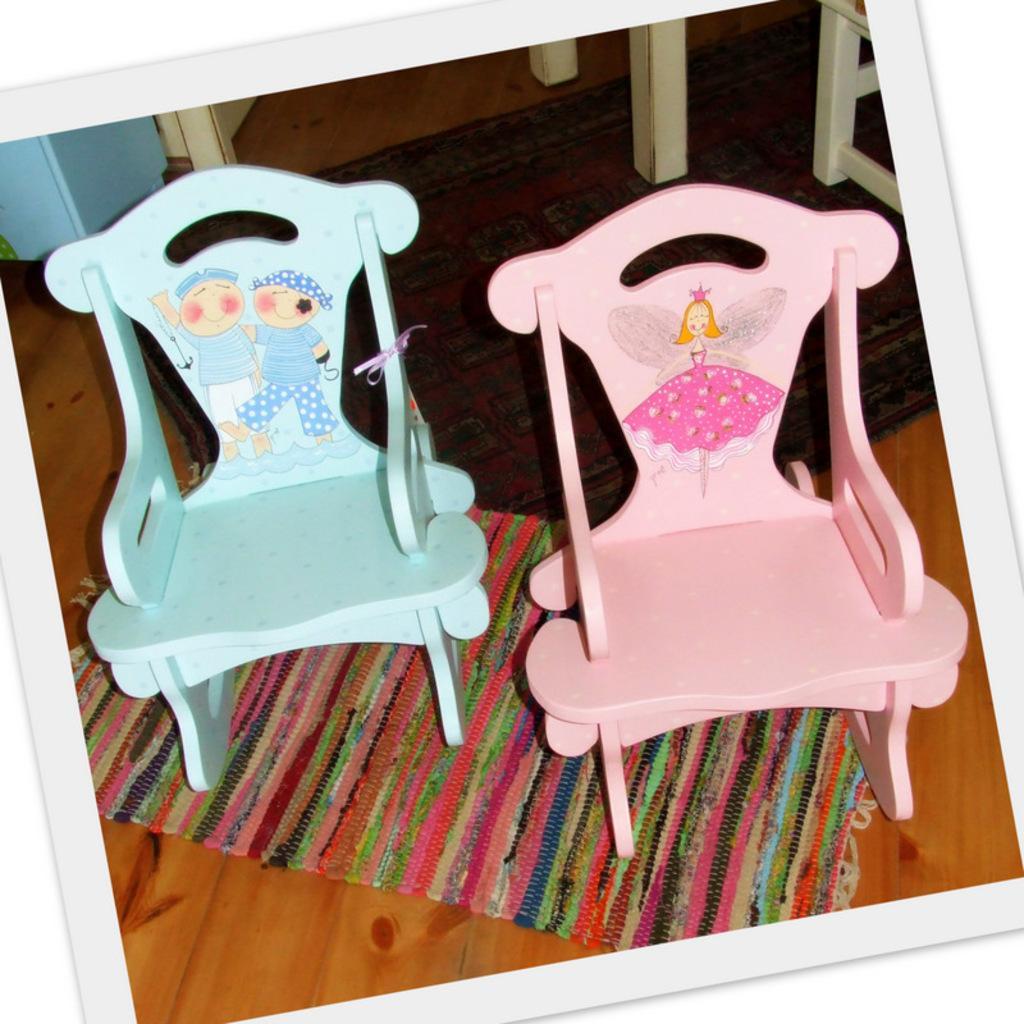Describe this image in one or two sentences. This is a picture of two chairs on the which are in blue and pink in color and there is a drawing of two cartoons on blue chair and a girl cartoon on the pink chair and the mat is in different colors like pink, orange, yellow, white, black and green. 